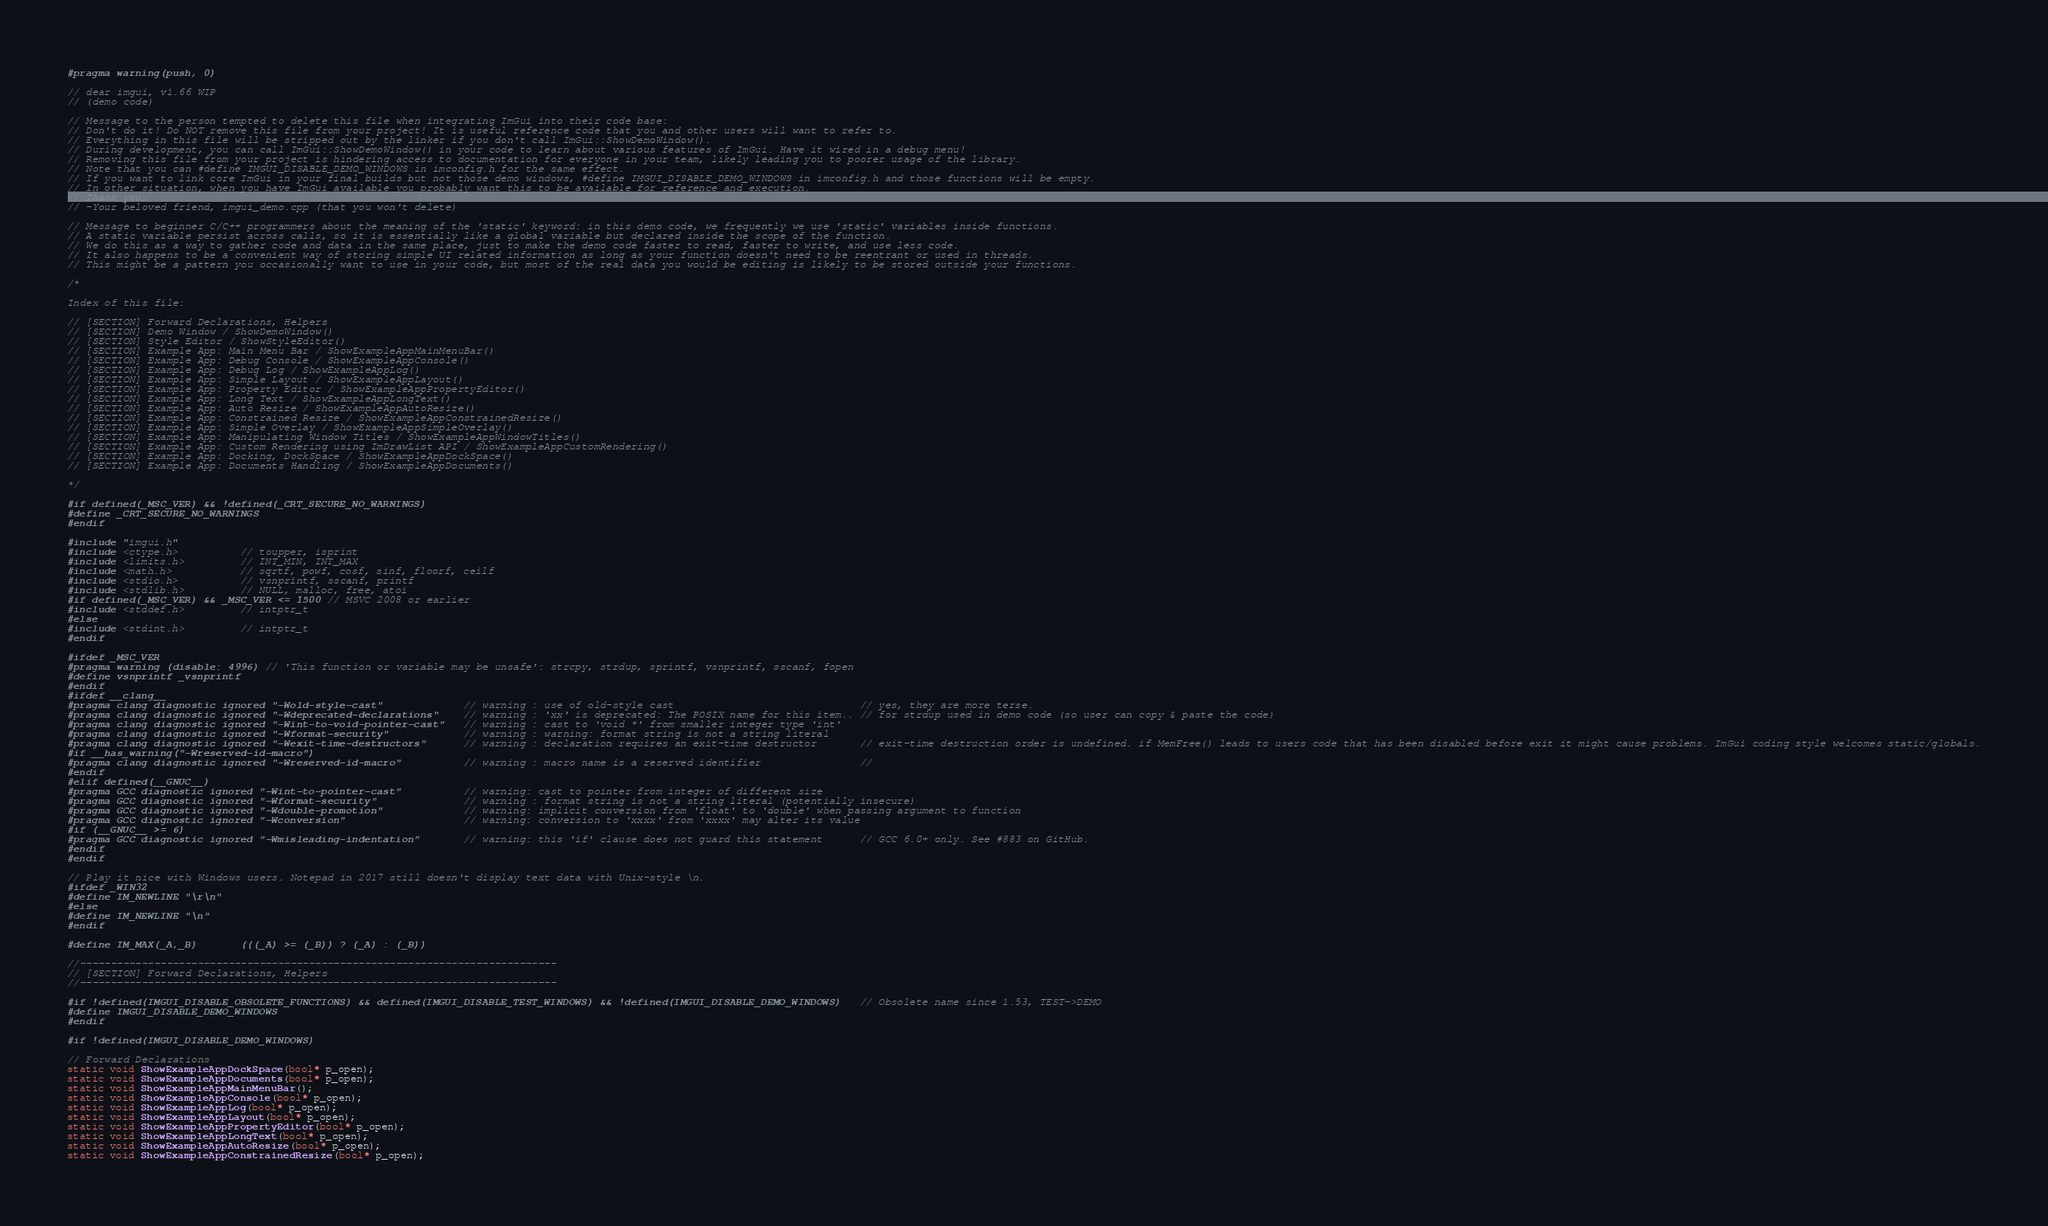<code> <loc_0><loc_0><loc_500><loc_500><_C++_>#pragma warning(push, 0)

// dear imgui, v1.66 WIP
// (demo code)

// Message to the person tempted to delete this file when integrating ImGui into their code base:
// Don't do it! Do NOT remove this file from your project! It is useful reference code that you and other users will want to refer to.
// Everything in this file will be stripped out by the linker if you don't call ImGui::ShowDemoWindow().
// During development, you can call ImGui::ShowDemoWindow() in your code to learn about various features of ImGui. Have it wired in a debug menu!
// Removing this file from your project is hindering access to documentation for everyone in your team, likely leading you to poorer usage of the library.
// Note that you can #define IMGUI_DISABLE_DEMO_WINDOWS in imconfig.h for the same effect.
// If you want to link core ImGui in your final builds but not those demo windows, #define IMGUI_DISABLE_DEMO_WINDOWS in imconfig.h and those functions will be empty.
// In other situation, when you have ImGui available you probably want this to be available for reference and execution.
// Thank you,
// -Your beloved friend, imgui_demo.cpp (that you won't delete)

// Message to beginner C/C++ programmers about the meaning of the 'static' keyword: in this demo code, we frequently we use 'static' variables inside functions.
// A static variable persist across calls, so it is essentially like a global variable but declared inside the scope of the function.
// We do this as a way to gather code and data in the same place, just to make the demo code faster to read, faster to write, and use less code.
// It also happens to be a convenient way of storing simple UI related information as long as your function doesn't need to be reentrant or used in threads.
// This might be a pattern you occasionally want to use in your code, but most of the real data you would be editing is likely to be stored outside your functions.

/*

Index of this file:

// [SECTION] Forward Declarations, Helpers
// [SECTION] Demo Window / ShowDemoWindow()
// [SECTION] Style Editor / ShowStyleEditor()
// [SECTION] Example App: Main Menu Bar / ShowExampleAppMainMenuBar()
// [SECTION] Example App: Debug Console / ShowExampleAppConsole()
// [SECTION] Example App: Debug Log / ShowExampleAppLog()
// [SECTION] Example App: Simple Layout / ShowExampleAppLayout()
// [SECTION] Example App: Property Editor / ShowExampleAppPropertyEditor()
// [SECTION] Example App: Long Text / ShowExampleAppLongText()
// [SECTION] Example App: Auto Resize / ShowExampleAppAutoResize()
// [SECTION] Example App: Constrained Resize / ShowExampleAppConstrainedResize()
// [SECTION] Example App: Simple Overlay / ShowExampleAppSimpleOverlay()
// [SECTION] Example App: Manipulating Window Titles / ShowExampleAppWindowTitles()
// [SECTION] Example App: Custom Rendering using ImDrawList API / ShowExampleAppCustomRendering()
// [SECTION] Example App: Docking, DockSpace / ShowExampleAppDockSpace()
// [SECTION] Example App: Documents Handling / ShowExampleAppDocuments()

*/

#if defined(_MSC_VER) && !defined(_CRT_SECURE_NO_WARNINGS)
#define _CRT_SECURE_NO_WARNINGS
#endif

#include "imgui.h"
#include <ctype.h>          // toupper, isprint
#include <limits.h>         // INT_MIN, INT_MAX
#include <math.h>           // sqrtf, powf, cosf, sinf, floorf, ceilf
#include <stdio.h>          // vsnprintf, sscanf, printf
#include <stdlib.h>         // NULL, malloc, free, atoi
#if defined(_MSC_VER) && _MSC_VER <= 1500 // MSVC 2008 or earlier
#include <stddef.h>         // intptr_t
#else
#include <stdint.h>         // intptr_t
#endif

#ifdef _MSC_VER
#pragma warning (disable: 4996) // 'This function or variable may be unsafe': strcpy, strdup, sprintf, vsnprintf, sscanf, fopen
#define vsnprintf _vsnprintf
#endif
#ifdef __clang__
#pragma clang diagnostic ignored "-Wold-style-cast"             // warning : use of old-style cast                              // yes, they are more terse.
#pragma clang diagnostic ignored "-Wdeprecated-declarations"    // warning : 'xx' is deprecated: The POSIX name for this item.. // for strdup used in demo code (so user can copy & paste the code)
#pragma clang diagnostic ignored "-Wint-to-void-pointer-cast"   // warning : cast to 'void *' from smaller integer type 'int'
#pragma clang diagnostic ignored "-Wformat-security"            // warning : warning: format string is not a string literal
#pragma clang diagnostic ignored "-Wexit-time-destructors"      // warning : declaration requires an exit-time destructor       // exit-time destruction order is undefined. if MemFree() leads to users code that has been disabled before exit it might cause problems. ImGui coding style welcomes static/globals.
#if __has_warning("-Wreserved-id-macro")
#pragma clang diagnostic ignored "-Wreserved-id-macro"          // warning : macro name is a reserved identifier                //
#endif
#elif defined(__GNUC__)
#pragma GCC diagnostic ignored "-Wint-to-pointer-cast"          // warning: cast to pointer from integer of different size
#pragma GCC diagnostic ignored "-Wformat-security"              // warning : format string is not a string literal (potentially insecure)
#pragma GCC diagnostic ignored "-Wdouble-promotion"             // warning: implicit conversion from 'float' to 'double' when passing argument to function
#pragma GCC diagnostic ignored "-Wconversion"                   // warning: conversion to 'xxxx' from 'xxxx' may alter its value
#if (__GNUC__ >= 6)
#pragma GCC diagnostic ignored "-Wmisleading-indentation"       // warning: this 'if' clause does not guard this statement      // GCC 6.0+ only. See #883 on GitHub.
#endif
#endif

// Play it nice with Windows users. Notepad in 2017 still doesn't display text data with Unix-style \n.
#ifdef _WIN32
#define IM_NEWLINE "\r\n"
#else
#define IM_NEWLINE "\n"
#endif

#define IM_MAX(_A,_B)       (((_A) >= (_B)) ? (_A) : (_B))

//-----------------------------------------------------------------------------
// [SECTION] Forward Declarations, Helpers
//-----------------------------------------------------------------------------

#if !defined(IMGUI_DISABLE_OBSOLETE_FUNCTIONS) && defined(IMGUI_DISABLE_TEST_WINDOWS) && !defined(IMGUI_DISABLE_DEMO_WINDOWS)   // Obsolete name since 1.53, TEST->DEMO
#define IMGUI_DISABLE_DEMO_WINDOWS
#endif

#if !defined(IMGUI_DISABLE_DEMO_WINDOWS)

// Forward Declarations
static void ShowExampleAppDockSpace(bool* p_open);
static void ShowExampleAppDocuments(bool* p_open);
static void ShowExampleAppMainMenuBar();
static void ShowExampleAppConsole(bool* p_open);
static void ShowExampleAppLog(bool* p_open);
static void ShowExampleAppLayout(bool* p_open);
static void ShowExampleAppPropertyEditor(bool* p_open);
static void ShowExampleAppLongText(bool* p_open);
static void ShowExampleAppAutoResize(bool* p_open);
static void ShowExampleAppConstrainedResize(bool* p_open);</code> 